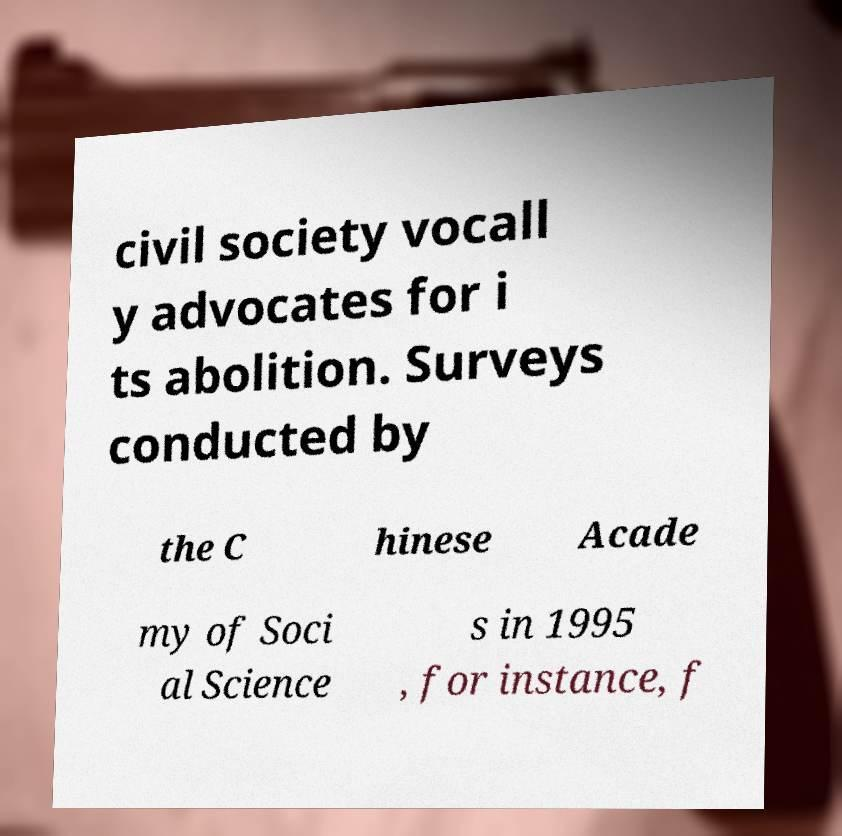I need the written content from this picture converted into text. Can you do that? civil society vocall y advocates for i ts abolition. Surveys conducted by the C hinese Acade my of Soci al Science s in 1995 , for instance, f 